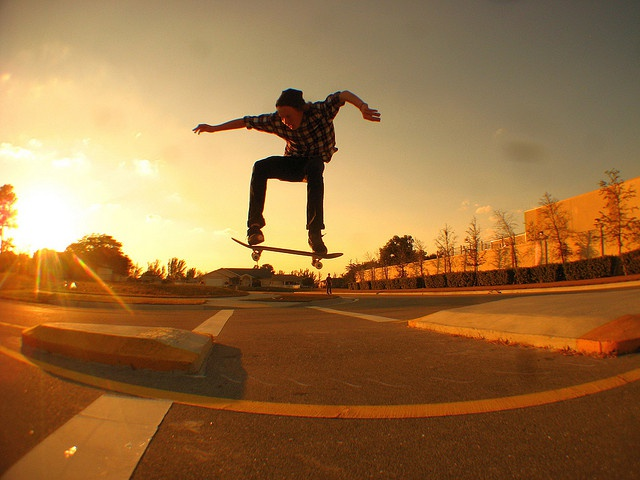Describe the objects in this image and their specific colors. I can see people in gray, black, maroon, and khaki tones, skateboard in gray, maroon, khaki, and black tones, and people in gray, black, maroon, and brown tones in this image. 